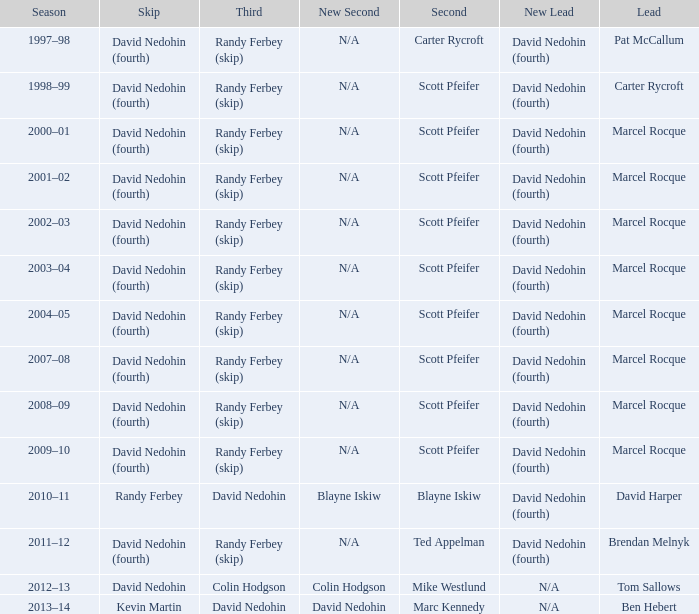Which Third has a Second of scott pfeifer? Randy Ferbey (skip), Randy Ferbey (skip), Randy Ferbey (skip), Randy Ferbey (skip), Randy Ferbey (skip), Randy Ferbey (skip), Randy Ferbey (skip), Randy Ferbey (skip), Randy Ferbey (skip). 